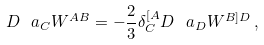<formula> <loc_0><loc_0><loc_500><loc_500>D ^ { \ } a _ { C } W ^ { A B } = - \frac { 2 } { 3 } \delta ^ { [ A } _ { C } D ^ { \ } a _ { D } W ^ { B ] D } \, ,</formula> 